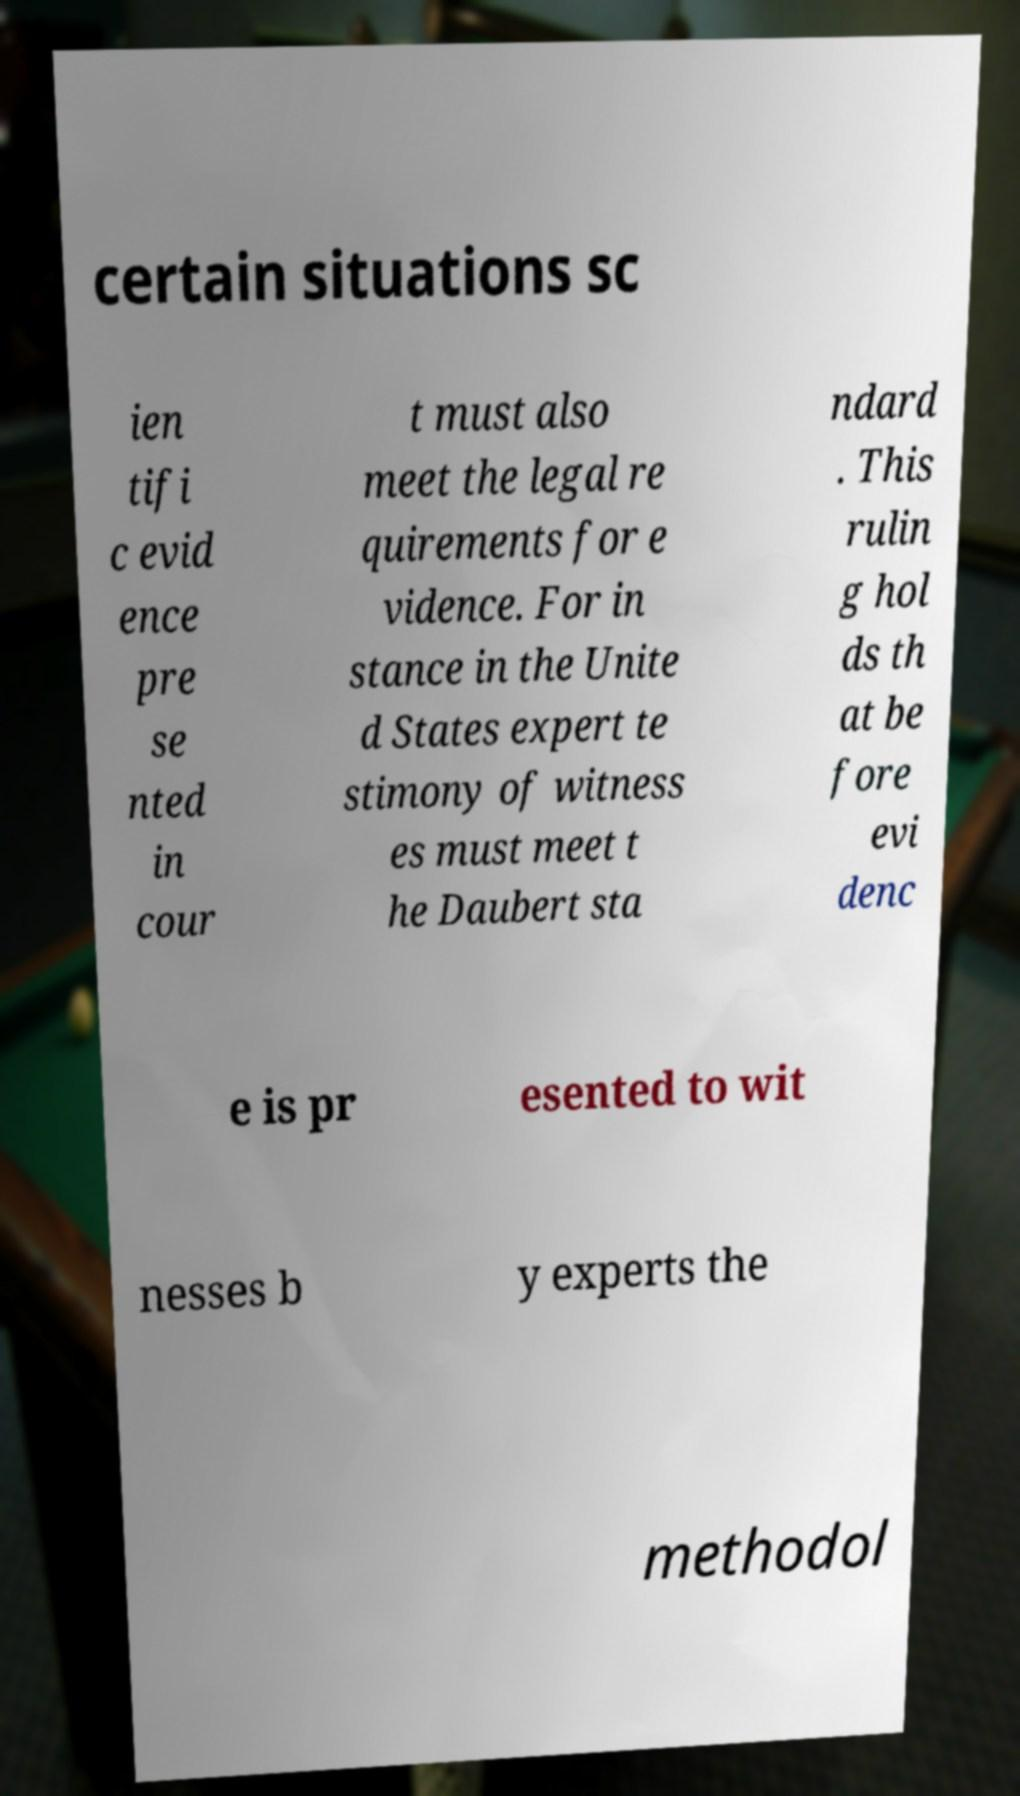Could you extract and type out the text from this image? certain situations sc ien tifi c evid ence pre se nted in cour t must also meet the legal re quirements for e vidence. For in stance in the Unite d States expert te stimony of witness es must meet t he Daubert sta ndard . This rulin g hol ds th at be fore evi denc e is pr esented to wit nesses b y experts the methodol 